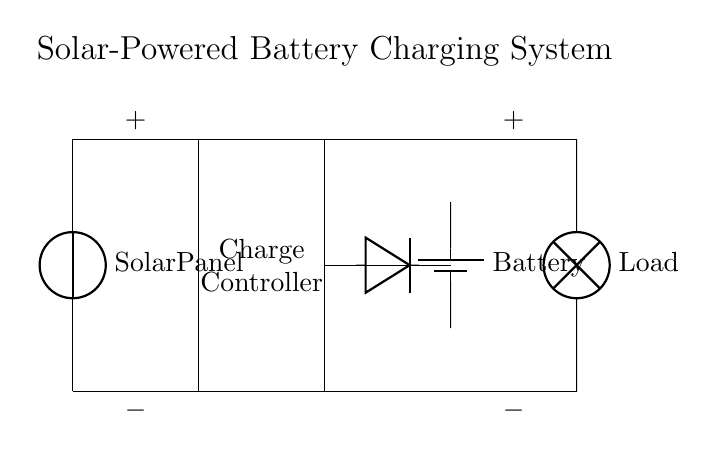What is the main component that converts solar energy to electrical energy? The main component is the solar panel, which is depicted at the top of the circuit diagram. It collects sunlight and converts it into DC electricity.
Answer: Solar Panel What is the purpose of the charge controller in this circuit? The charge controller regulates the voltage and current coming from the solar panel to prevent overcharging the battery. It ensures the battery receives an appropriate charge level.
Answer: Regulate charging How many components are connected in series in this circuit? There are two main series connections: the solar panel and charge controller connect to the battery, and the battery connects to the load. Overall, there are four components linked in series from the solar panel to the load via the charge controller and battery.
Answer: Four What does the diode do in this circuit? The diode only allows current to flow in one direction, preventing potential backflow of current from the battery to the solar panel, which can occur when the solar panel is not generating power (e.g., at night).
Answer: Prevent backflow What is the role of the battery in the solar-powered system? The battery stores the electrical energy produced by the solar panel and provides power to the load when solar energy is not available, ensuring a continuous supply of energy.
Answer: Store energy What is the load connected to in this circuit? The load is connected to the output of the battery, which is shown on the right side of the circuit diagram. The load represents the devices or appliances powered by this solar system.
Answer: Battery 